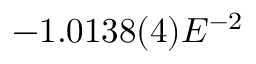Convert formula to latex. <formula><loc_0><loc_0><loc_500><loc_500>- 1 . 0 1 3 8 ( 4 ) E ^ { - 2 }</formula> 